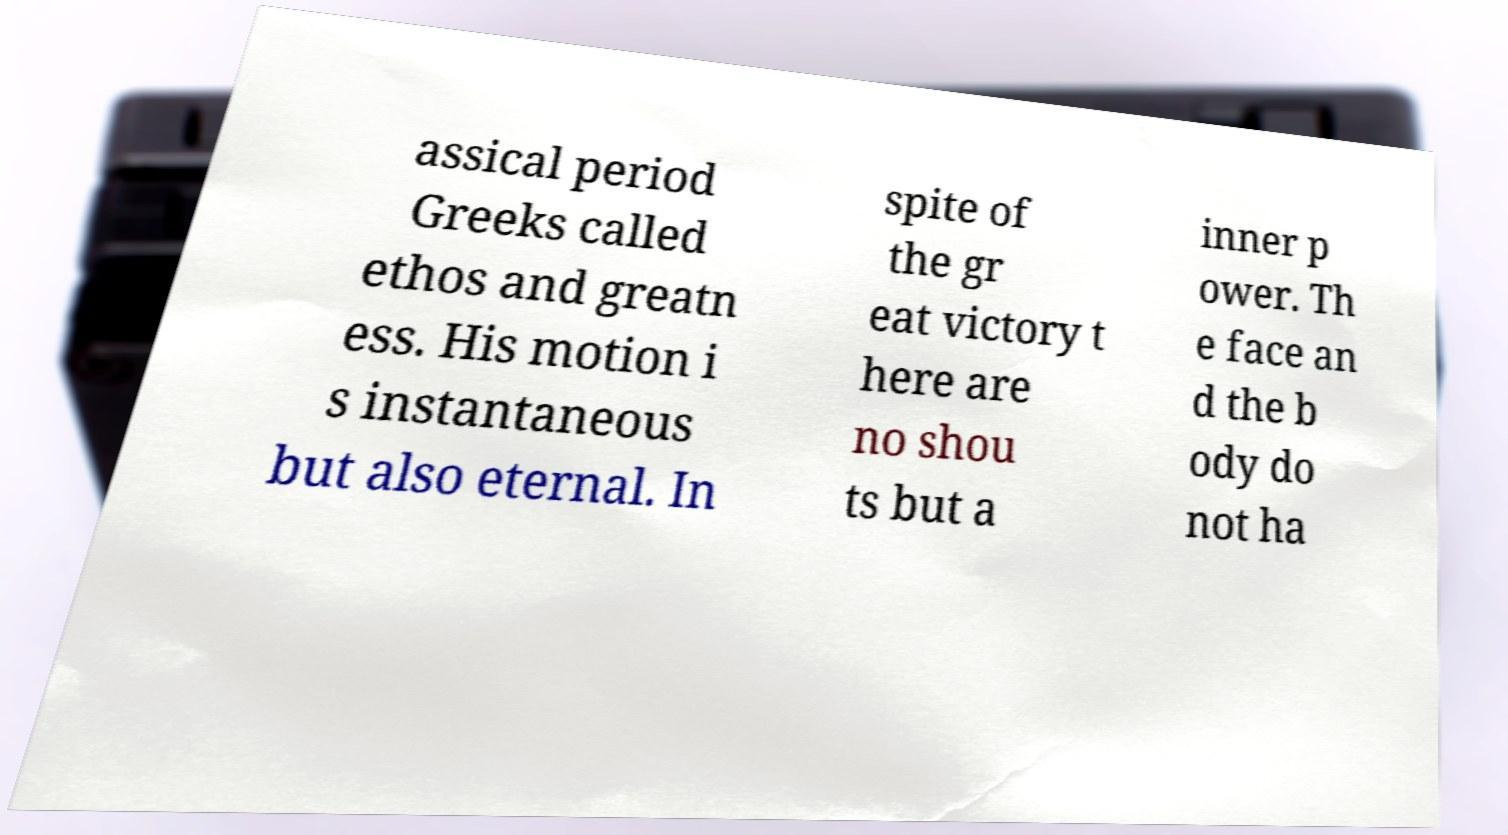What messages or text are displayed in this image? I need them in a readable, typed format. assical period Greeks called ethos and greatn ess. His motion i s instantaneous but also eternal. In spite of the gr eat victory t here are no shou ts but a inner p ower. Th e face an d the b ody do not ha 